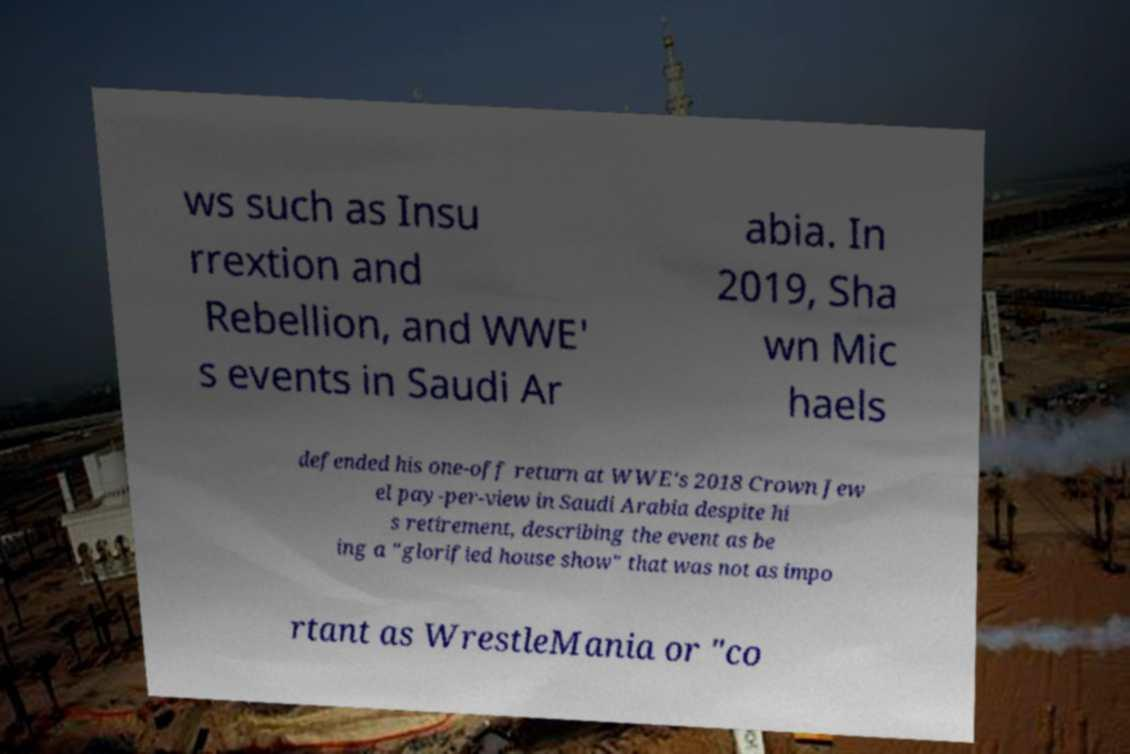There's text embedded in this image that I need extracted. Can you transcribe it verbatim? ws such as Insu rrextion and Rebellion, and WWE' s events in Saudi Ar abia. In 2019, Sha wn Mic haels defended his one-off return at WWE's 2018 Crown Jew el pay-per-view in Saudi Arabia despite hi s retirement, describing the event as be ing a "glorified house show" that was not as impo rtant as WrestleMania or "co 